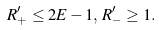Convert formula to latex. <formula><loc_0><loc_0><loc_500><loc_500>R ^ { \prime } _ { + } \leq 2 E - 1 , \, R ^ { \prime } _ { - } \geq 1 .</formula> 